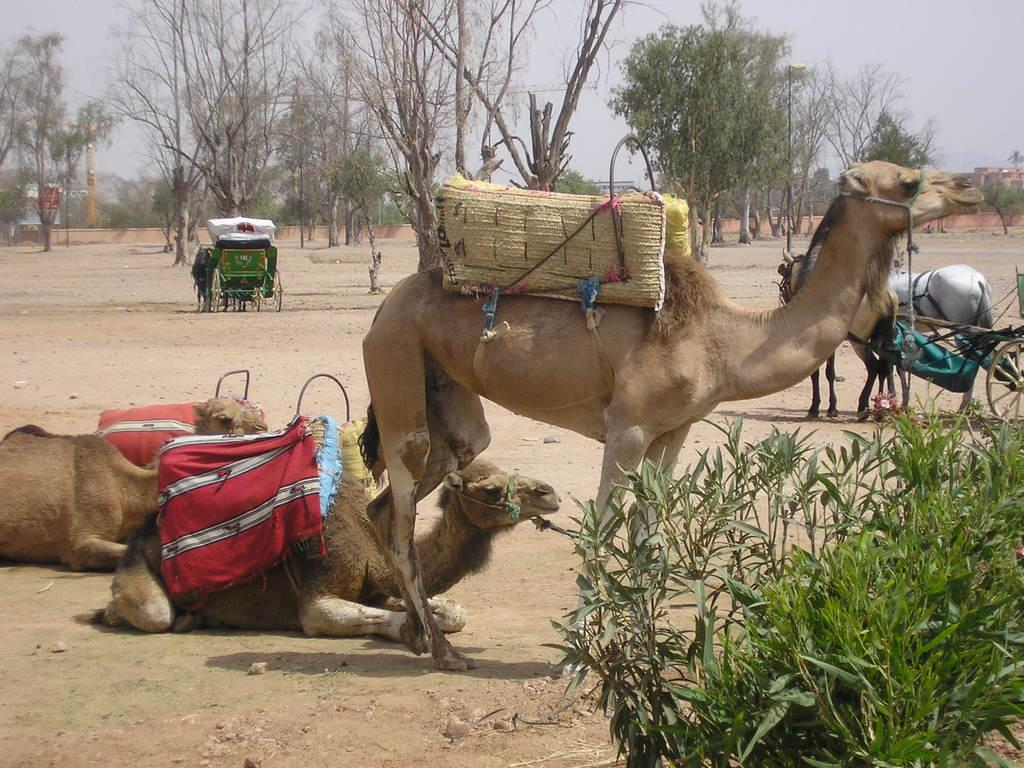What type of animal is standing on the right side of the image? There is a camel standing on the right side of the image. How many camels are sitting on the left side of the image? There are two camels sitting on the left side of the image. What can be seen in the middle of the image? There are trees in the middle of the image. What type of quartz can be seen in the image? There is no quartz present in the image. Can you tell me how many pigs are visible in the image? There are no pigs present in the image; it features camels and trees. 